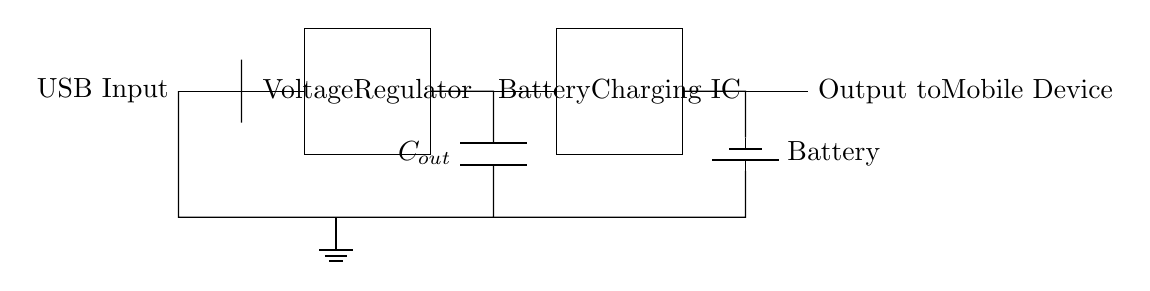What is the input type for this circuit? The input type is USB, which is indicated at the left side of the circuit where it specifies "USB Input".
Answer: USB What component regulates the voltage in this circuit? The voltage regulator, which is labeled as such in a rectangular box that spans from coordinates (2,-1) to (4,1), is responsible for regulating the voltage.
Answer: Voltage Regulator What does the capacitor labeled C_out do? The capacitor labeled C_out is used to smooth out voltage fluctuations and provide stable output to the battery charging IC, as it connects the output of the voltage regulator to the input of the battery charging IC.
Answer: Stabilization Which component is responsible for managing the battery charging process? The battery charging IC is responsible for managing the battery charging, as it is specifically labeled in the diagram, placed at (6,-1) to (8,1).
Answer: Battery Charging IC What is the output voltage expected from this circuit? The typical output voltage expected for USB charging is 5 volts, as inferred from standard USB specifications, which correlate with the input described in the circuit.
Answer: 5 volts How is the battery connected to the circuit? The battery is connected to the circuit through a connection from the battery charging IC, where one terminal connects to the output and the other terminal is grounded, showcasing its integration within the charging circuit.
Answer: Battery Charging IC What type of battery is symbolized in the circuit? The battery is represented using a standard battery symbol in the circuit diagram, indicating it is a rechargeable battery typically used for mobile devices.
Answer: Rechargeable 